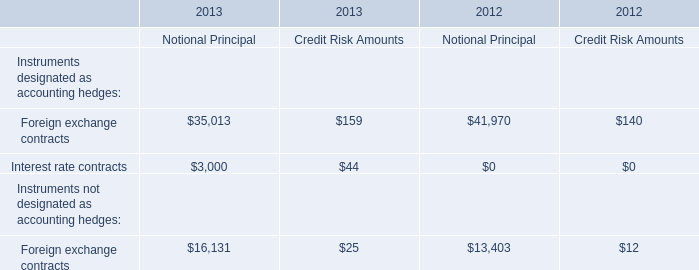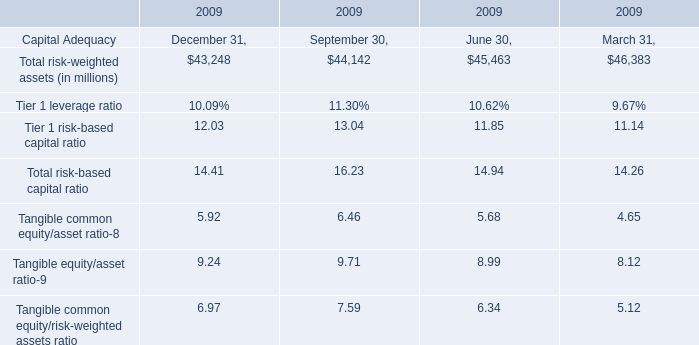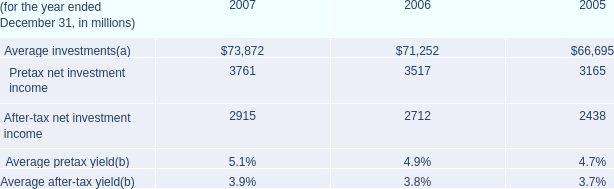What is the sum of Total risk-weighted assets in September 30, 2009 and Pretax net investment income in 2005? (in million) 
Computations: (44142 + 3165)
Answer: 47307.0. 